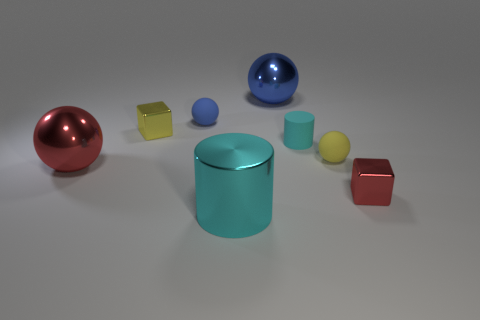Add 2 big metal objects. How many objects exist? 10 Subtract all red blocks. How many blocks are left? 1 Subtract all tiny yellow spheres. How many spheres are left? 3 Subtract all cubes. How many objects are left? 6 Add 3 tiny yellow metal balls. How many tiny yellow metal balls exist? 3 Subtract 0 cyan cubes. How many objects are left? 8 Subtract 1 cylinders. How many cylinders are left? 1 Subtract all purple cylinders. Subtract all purple balls. How many cylinders are left? 2 Subtract all yellow balls. How many gray blocks are left? 0 Subtract all shiny balls. Subtract all small cyan rubber things. How many objects are left? 5 